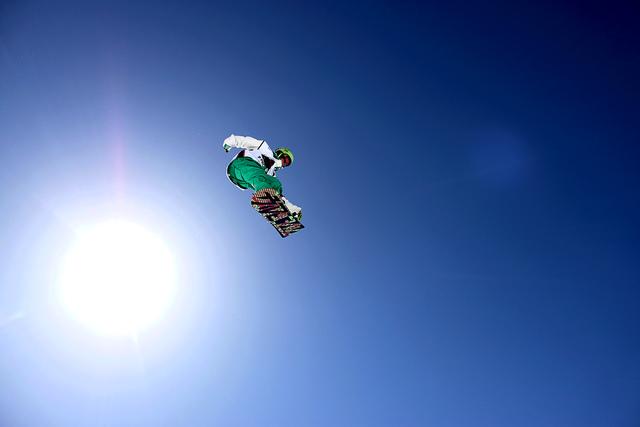Is this photo taken from below?
Concise answer only. Yes. What color are the person's pants?
Concise answer only. Green. Is the person riding a hoverboard?
Concise answer only. No. What is the primary color of the snowboard?
Concise answer only. Black. Is this a sunny picture?
Keep it brief. Yes. 